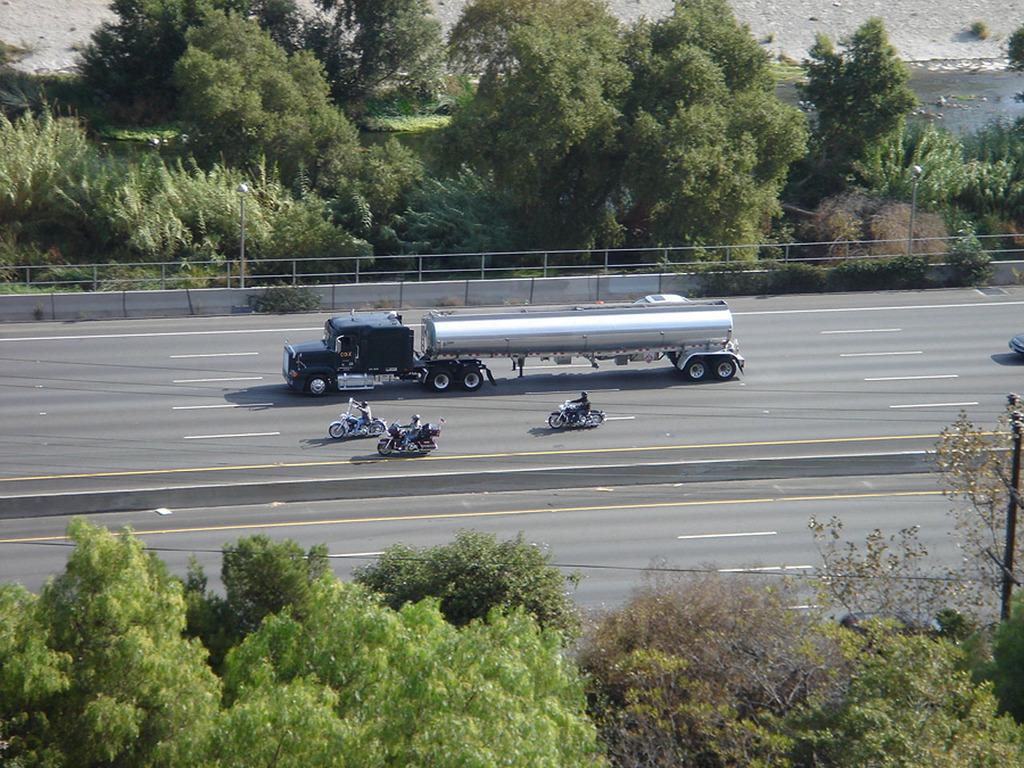What are the persons in the image doing? The persons in the image are riding vehicles on the road. What can be seen at the bottom of the image? Trees are visible at the bottom of the image. What is visible in the background of the image? Trees, poles, a fence, and water are visible in the background of the image. Can you tell me how many snails are crawling on the fence in the image? There are no snails visible in the image; the fence is in the background, and no snails are present. What type of jam is being spread on the poles in the image? There is no jam present in the image; the poles are in the background, and no jam or spreading activity is depicted. 